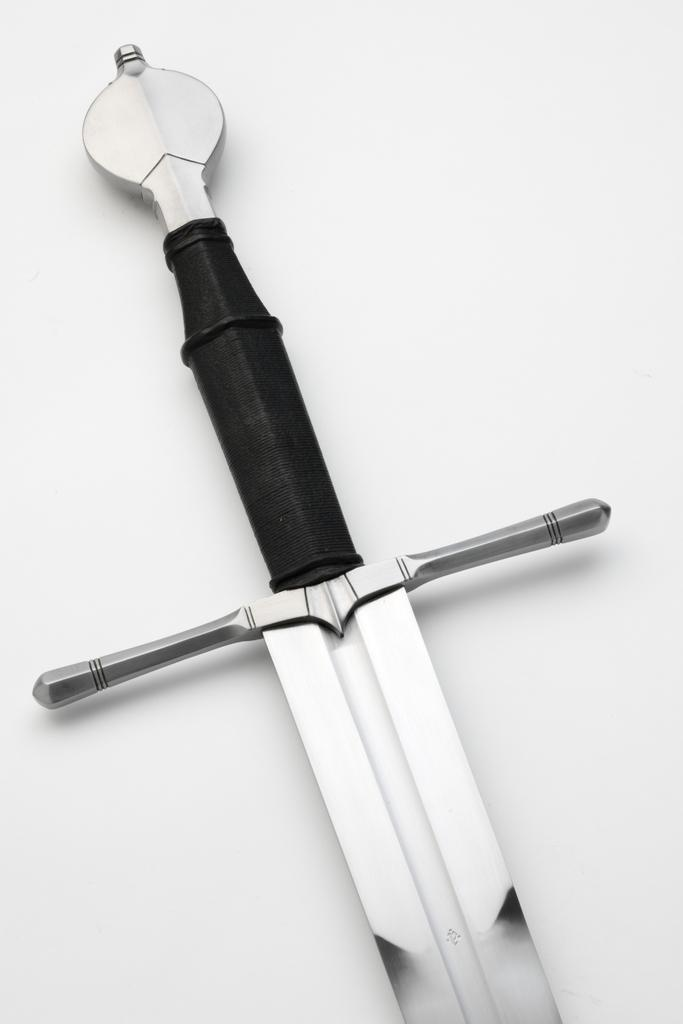What object is present in the image that is typically used as a weapon? There is a sword in the image. On what surface is the sword placed? The sword is placed on a white color surface. What type of horn can be seen attached to the sword in the image? There is no horn attached to the sword in the image. What action is the sword performing in the image? The sword is not performing any action in the image; it is stationary on the white color surface. 